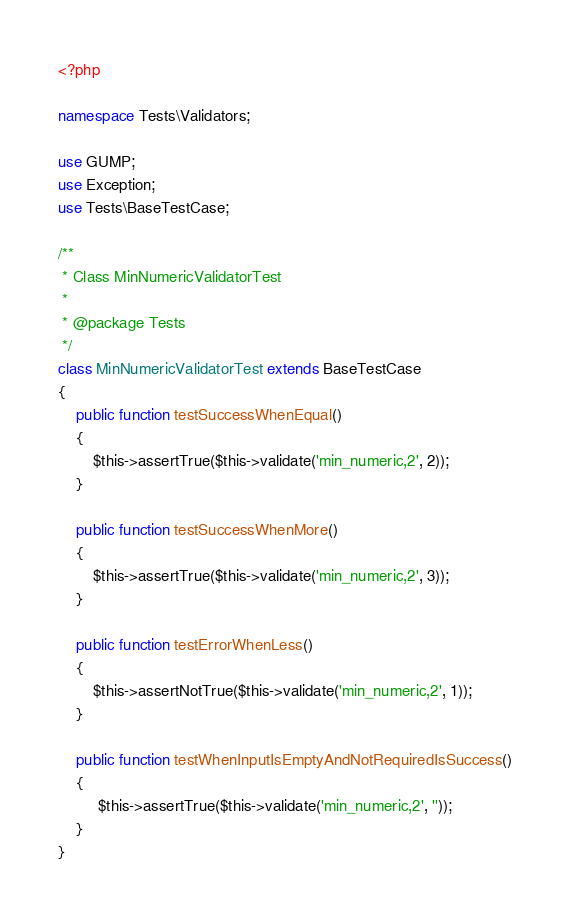<code> <loc_0><loc_0><loc_500><loc_500><_PHP_><?php

namespace Tests\Validators;

use GUMP;
use Exception;
use Tests\BaseTestCase;

/**
 * Class MinNumericValidatorTest
 *
 * @package Tests
 */
class MinNumericValidatorTest extends BaseTestCase
{
    public function testSuccessWhenEqual()
    {
        $this->assertTrue($this->validate('min_numeric,2', 2));
    }

    public function testSuccessWhenMore()
    {
        $this->assertTrue($this->validate('min_numeric,2', 3));
    }

    public function testErrorWhenLess()
    {
        $this->assertNotTrue($this->validate('min_numeric,2', 1));
    }

    public function testWhenInputIsEmptyAndNotRequiredIsSuccess()
    {
         $this->assertTrue($this->validate('min_numeric,2', ''));
    }
}</code> 